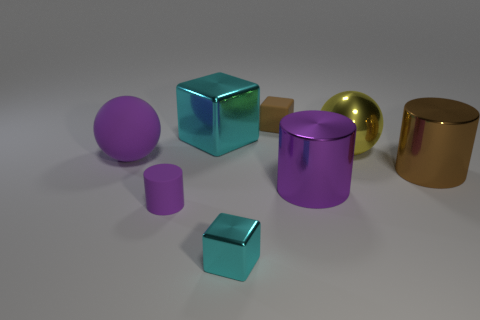There is a brown object in front of the small brown cube; does it have the same shape as the yellow thing?
Offer a very short reply. No. Are there more brown metallic objects that are to the right of the large rubber object than big brown cylinders that are behind the yellow ball?
Your answer should be compact. Yes. How many other things are there of the same size as the brown cylinder?
Provide a short and direct response. 4. Is the shape of the yellow metallic object the same as the small matte object on the right side of the purple matte cylinder?
Provide a succinct answer. No. How many matte objects are either big yellow things or brown blocks?
Offer a very short reply. 1. Is there another matte thing that has the same color as the large rubber object?
Provide a short and direct response. Yes. Is there a large blue matte sphere?
Provide a short and direct response. No. Is the big purple metallic object the same shape as the large yellow object?
Your response must be concise. No. What number of big things are either purple cylinders or purple matte objects?
Offer a terse response. 2. What color is the tiny metallic thing?
Ensure brevity in your answer.  Cyan. 